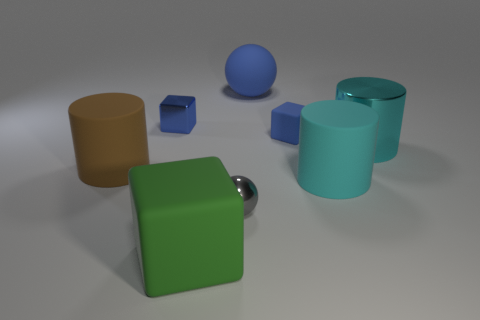Is there anything else that is the same shape as the small blue rubber thing?
Provide a succinct answer. Yes. There is a large cyan object that is in front of the brown rubber thing; what is its material?
Provide a short and direct response. Rubber. What is the size of the other rubber object that is the same shape as the green object?
Give a very brief answer. Small. What number of other tiny gray objects are made of the same material as the gray thing?
Your response must be concise. 0. How many rubber things have the same color as the tiny shiny cube?
Your response must be concise. 2. What number of things are big cyan metal things to the right of the brown cylinder or matte things that are right of the brown object?
Make the answer very short. 5. Are there fewer large rubber things that are on the right side of the tiny blue shiny block than matte objects?
Provide a succinct answer. Yes. Is there a brown object that has the same size as the gray metallic object?
Provide a succinct answer. No. What color is the metallic cylinder?
Keep it short and to the point. Cyan. Is the metal cylinder the same size as the blue metal block?
Your response must be concise. No. 